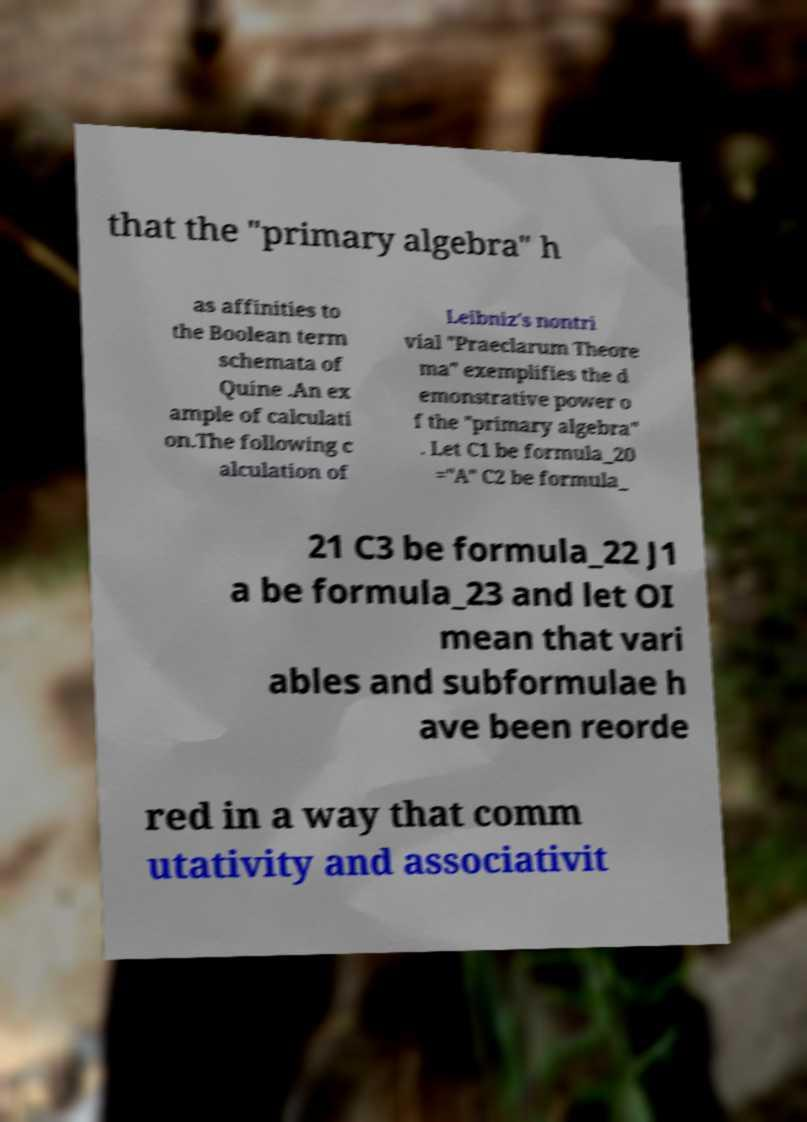Could you assist in decoding the text presented in this image and type it out clearly? that the "primary algebra" h as affinities to the Boolean term schemata of Quine .An ex ample of calculati on.The following c alculation of Leibniz's nontri vial "Praeclarum Theore ma" exemplifies the d emonstrative power o f the "primary algebra" . Let C1 be formula_20 ="A" C2 be formula_ 21 C3 be formula_22 J1 a be formula_23 and let OI mean that vari ables and subformulae h ave been reorde red in a way that comm utativity and associativit 